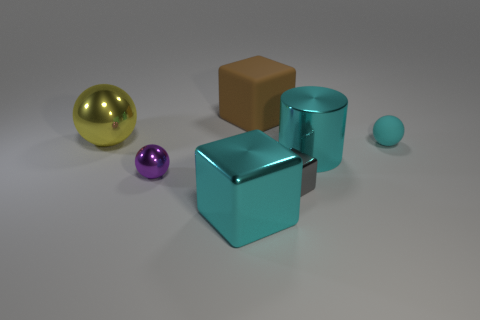What number of other things are the same size as the brown rubber cube?
Provide a succinct answer. 3. How many other things are there of the same shape as the brown object?
Keep it short and to the point. 2. How many other things are there of the same material as the gray object?
Offer a very short reply. 4. The other yellow thing that is the same shape as the small matte object is what size?
Keep it short and to the point. Large. Do the big metal block and the tiny rubber thing have the same color?
Provide a short and direct response. Yes. There is a sphere that is both behind the big cyan cylinder and in front of the large yellow metal object; what is its color?
Provide a succinct answer. Cyan. What number of things are either blocks that are behind the cyan shiny cube or things?
Give a very brief answer. 7. The other tiny rubber thing that is the same shape as the yellow thing is what color?
Your answer should be compact. Cyan. There is a large yellow object; does it have the same shape as the purple thing that is in front of the big rubber cube?
Give a very brief answer. Yes. How many objects are metal balls that are to the right of the yellow metal thing or metal spheres that are in front of the large yellow sphere?
Your response must be concise. 1. 